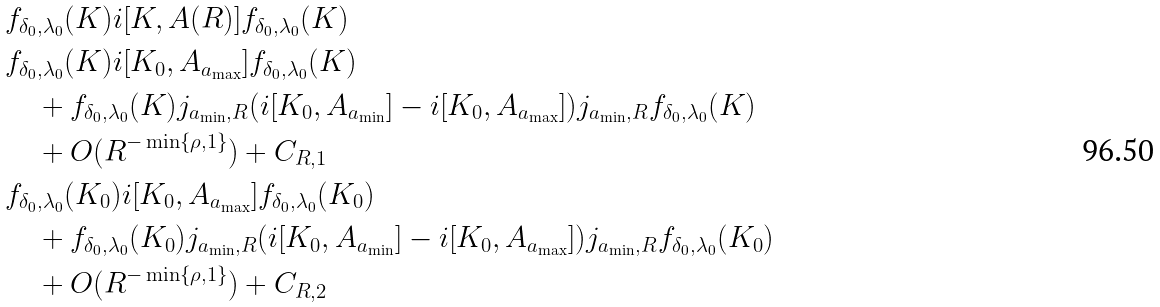<formula> <loc_0><loc_0><loc_500><loc_500>& f _ { \delta _ { 0 } , \lambda _ { 0 } } ( K ) i [ K , A ( R ) ] f _ { \delta _ { 0 } , \lambda _ { 0 } } ( K ) \\ & f _ { \delta _ { 0 } , \lambda _ { 0 } } ( K ) i [ K _ { 0 } , A _ { a _ { \max } } ] f _ { \delta _ { 0 } , \lambda _ { 0 } } ( K ) \\ & \quad + f _ { \delta _ { 0 } , \lambda _ { 0 } } ( K ) j _ { a _ { \min } , R } ( i [ K _ { 0 } , A _ { a _ { \min } } ] - i [ K _ { 0 } , A _ { a _ { \max } } ] ) j _ { a _ { \min } , R } f _ { \delta _ { 0 } , \lambda _ { 0 } } ( K ) \\ & \quad + O ( R ^ { - \min \{ \rho , 1 \} } ) + C _ { R , 1 } \\ & f _ { \delta _ { 0 } , \lambda _ { 0 } } ( K _ { 0 } ) i [ K _ { 0 } , A _ { a _ { \max } } ] f _ { \delta _ { 0 } , \lambda _ { 0 } } ( K _ { 0 } ) \\ & \quad + f _ { \delta _ { 0 } , \lambda _ { 0 } } ( K _ { 0 } ) j _ { a _ { \min } , R } ( i [ K _ { 0 } , A _ { a _ { \min } } ] - i [ K _ { 0 } , A _ { a _ { \max } } ] ) j _ { a _ { \min } , R } f _ { \delta _ { 0 } , \lambda _ { 0 } } ( K _ { 0 } ) \\ & \quad + O ( R ^ { - \min \{ \rho , 1 \} } ) + C _ { R , 2 }</formula> 